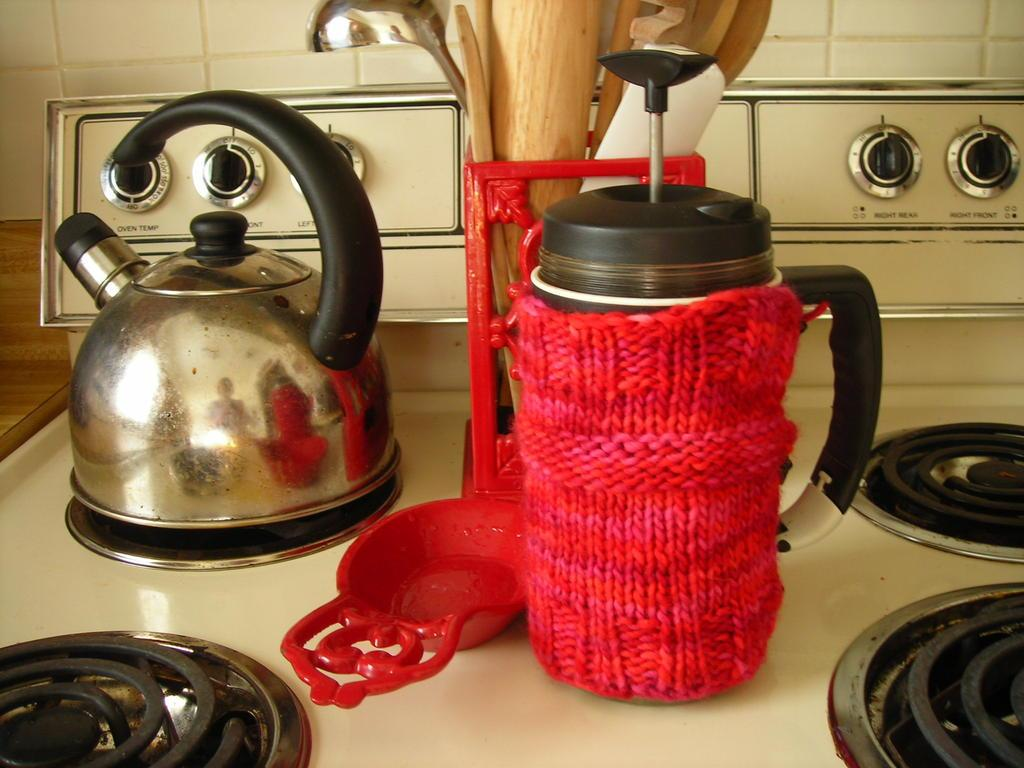<image>
Give a short and clear explanation of the subsequent image. A kitchen stove with Oven temperature labels underneath each stove burner button. 